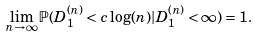Convert formula to latex. <formula><loc_0><loc_0><loc_500><loc_500>\lim _ { n \to \infty } \mathbb { P } ( D ^ { ( n ) } _ { 1 } < c \log ( n ) | D ^ { ( n ) } _ { 1 } < \infty ) = 1 .</formula> 